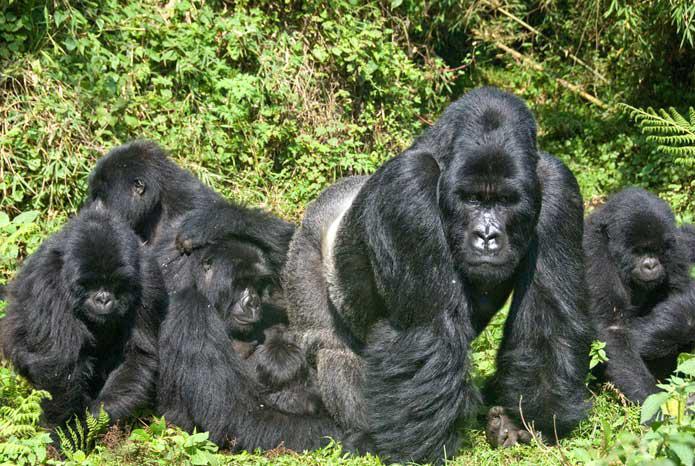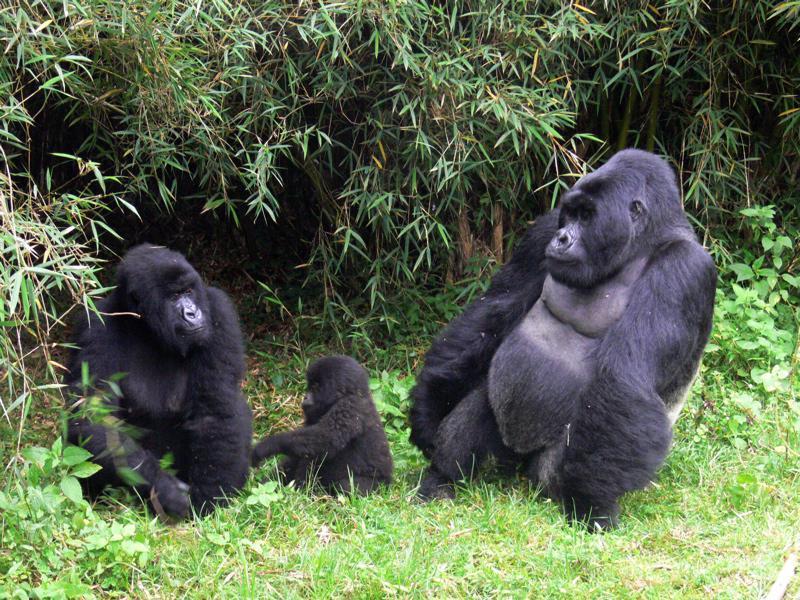The first image is the image on the left, the second image is the image on the right. Considering the images on both sides, is "The righthand image contains no more than two gorillas, including one with a big round belly." valid? Answer yes or no. No. The first image is the image on the left, the second image is the image on the right. For the images displayed, is the sentence "The right image contains no more than two gorillas." factually correct? Answer yes or no. No. 